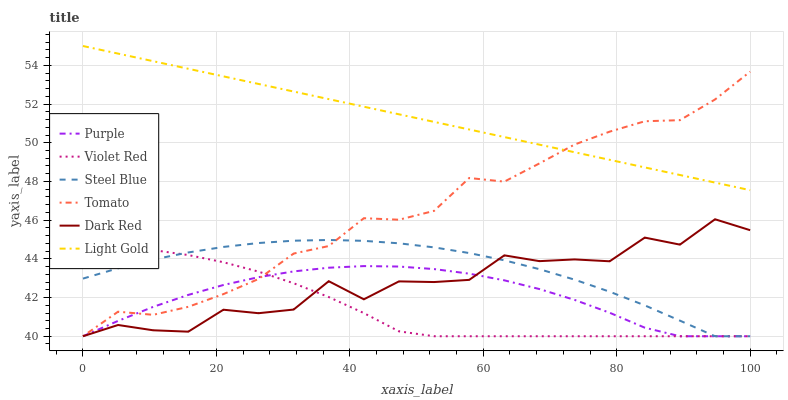Does Violet Red have the minimum area under the curve?
Answer yes or no. Yes. Does Light Gold have the maximum area under the curve?
Answer yes or no. Yes. Does Purple have the minimum area under the curve?
Answer yes or no. No. Does Purple have the maximum area under the curve?
Answer yes or no. No. Is Light Gold the smoothest?
Answer yes or no. Yes. Is Dark Red the roughest?
Answer yes or no. Yes. Is Violet Red the smoothest?
Answer yes or no. No. Is Violet Red the roughest?
Answer yes or no. No. Does Tomato have the lowest value?
Answer yes or no. Yes. Does Light Gold have the lowest value?
Answer yes or no. No. Does Light Gold have the highest value?
Answer yes or no. Yes. Does Violet Red have the highest value?
Answer yes or no. No. Is Purple less than Light Gold?
Answer yes or no. Yes. Is Light Gold greater than Purple?
Answer yes or no. Yes. Does Dark Red intersect Tomato?
Answer yes or no. Yes. Is Dark Red less than Tomato?
Answer yes or no. No. Is Dark Red greater than Tomato?
Answer yes or no. No. Does Purple intersect Light Gold?
Answer yes or no. No. 